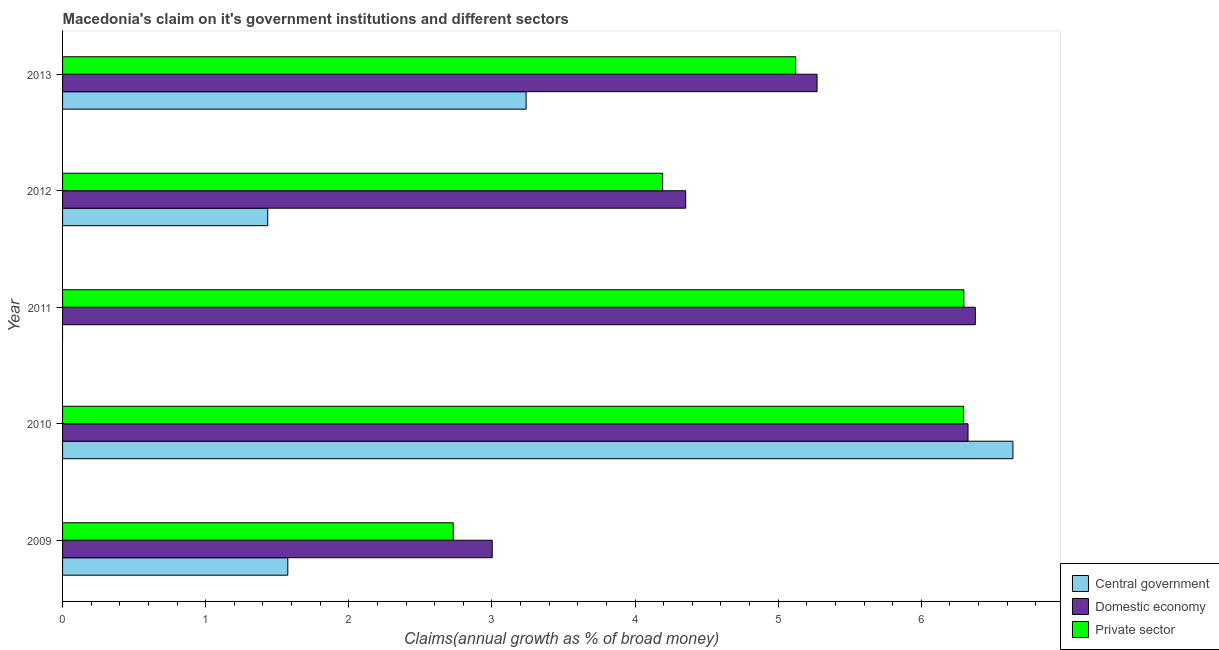How many different coloured bars are there?
Offer a terse response. 3. How many groups of bars are there?
Give a very brief answer. 5. How many bars are there on the 4th tick from the top?
Provide a succinct answer. 3. In how many cases, is the number of bars for a given year not equal to the number of legend labels?
Offer a terse response. 1. Across all years, what is the maximum percentage of claim on the central government?
Your answer should be compact. 6.64. Across all years, what is the minimum percentage of claim on the private sector?
Provide a short and direct response. 2.73. What is the total percentage of claim on the domestic economy in the graph?
Offer a terse response. 25.33. What is the difference between the percentage of claim on the central government in 2009 and that in 2012?
Give a very brief answer. 0.14. What is the difference between the percentage of claim on the central government in 2012 and the percentage of claim on the domestic economy in 2013?
Offer a terse response. -3.84. What is the average percentage of claim on the central government per year?
Your answer should be compact. 2.58. In the year 2009, what is the difference between the percentage of claim on the central government and percentage of claim on the domestic economy?
Your answer should be very brief. -1.43. What is the ratio of the percentage of claim on the central government in 2009 to that in 2010?
Provide a succinct answer. 0.24. What is the difference between the highest and the second highest percentage of claim on the central government?
Your answer should be compact. 3.4. What is the difference between the highest and the lowest percentage of claim on the private sector?
Give a very brief answer. 3.57. In how many years, is the percentage of claim on the central government greater than the average percentage of claim on the central government taken over all years?
Provide a succinct answer. 2. Is the sum of the percentage of claim on the private sector in 2009 and 2013 greater than the maximum percentage of claim on the central government across all years?
Offer a very short reply. Yes. Is it the case that in every year, the sum of the percentage of claim on the central government and percentage of claim on the domestic economy is greater than the percentage of claim on the private sector?
Give a very brief answer. Yes. Are all the bars in the graph horizontal?
Ensure brevity in your answer.  Yes. How many years are there in the graph?
Your answer should be very brief. 5. What is the difference between two consecutive major ticks on the X-axis?
Offer a terse response. 1. Does the graph contain grids?
Provide a succinct answer. No. How many legend labels are there?
Offer a very short reply. 3. What is the title of the graph?
Offer a terse response. Macedonia's claim on it's government institutions and different sectors. What is the label or title of the X-axis?
Ensure brevity in your answer.  Claims(annual growth as % of broad money). What is the Claims(annual growth as % of broad money) in Central government in 2009?
Provide a succinct answer. 1.57. What is the Claims(annual growth as % of broad money) of Domestic economy in 2009?
Provide a short and direct response. 3. What is the Claims(annual growth as % of broad money) in Private sector in 2009?
Make the answer very short. 2.73. What is the Claims(annual growth as % of broad money) in Central government in 2010?
Offer a terse response. 6.64. What is the Claims(annual growth as % of broad money) of Domestic economy in 2010?
Provide a short and direct response. 6.33. What is the Claims(annual growth as % of broad money) of Private sector in 2010?
Ensure brevity in your answer.  6.3. What is the Claims(annual growth as % of broad money) in Central government in 2011?
Provide a short and direct response. 0. What is the Claims(annual growth as % of broad money) of Domestic economy in 2011?
Your answer should be very brief. 6.38. What is the Claims(annual growth as % of broad money) of Private sector in 2011?
Provide a succinct answer. 6.3. What is the Claims(annual growth as % of broad money) of Central government in 2012?
Provide a succinct answer. 1.43. What is the Claims(annual growth as % of broad money) of Domestic economy in 2012?
Give a very brief answer. 4.35. What is the Claims(annual growth as % of broad money) of Private sector in 2012?
Keep it short and to the point. 4.19. What is the Claims(annual growth as % of broad money) in Central government in 2013?
Your answer should be very brief. 3.24. What is the Claims(annual growth as % of broad money) of Domestic economy in 2013?
Provide a succinct answer. 5.27. What is the Claims(annual growth as % of broad money) of Private sector in 2013?
Provide a short and direct response. 5.12. Across all years, what is the maximum Claims(annual growth as % of broad money) of Central government?
Your response must be concise. 6.64. Across all years, what is the maximum Claims(annual growth as % of broad money) of Domestic economy?
Your answer should be very brief. 6.38. Across all years, what is the maximum Claims(annual growth as % of broad money) in Private sector?
Ensure brevity in your answer.  6.3. Across all years, what is the minimum Claims(annual growth as % of broad money) in Domestic economy?
Your answer should be very brief. 3. Across all years, what is the minimum Claims(annual growth as % of broad money) in Private sector?
Make the answer very short. 2.73. What is the total Claims(annual growth as % of broad money) in Central government in the graph?
Keep it short and to the point. 12.89. What is the total Claims(annual growth as % of broad money) in Domestic economy in the graph?
Ensure brevity in your answer.  25.33. What is the total Claims(annual growth as % of broad money) in Private sector in the graph?
Keep it short and to the point. 24.64. What is the difference between the Claims(annual growth as % of broad money) of Central government in 2009 and that in 2010?
Offer a very short reply. -5.07. What is the difference between the Claims(annual growth as % of broad money) in Domestic economy in 2009 and that in 2010?
Give a very brief answer. -3.32. What is the difference between the Claims(annual growth as % of broad money) of Private sector in 2009 and that in 2010?
Give a very brief answer. -3.57. What is the difference between the Claims(annual growth as % of broad money) of Domestic economy in 2009 and that in 2011?
Give a very brief answer. -3.38. What is the difference between the Claims(annual growth as % of broad money) of Private sector in 2009 and that in 2011?
Keep it short and to the point. -3.57. What is the difference between the Claims(annual growth as % of broad money) of Central government in 2009 and that in 2012?
Your answer should be compact. 0.14. What is the difference between the Claims(annual growth as % of broad money) of Domestic economy in 2009 and that in 2012?
Make the answer very short. -1.35. What is the difference between the Claims(annual growth as % of broad money) in Private sector in 2009 and that in 2012?
Your answer should be compact. -1.46. What is the difference between the Claims(annual growth as % of broad money) in Central government in 2009 and that in 2013?
Give a very brief answer. -1.67. What is the difference between the Claims(annual growth as % of broad money) of Domestic economy in 2009 and that in 2013?
Your answer should be compact. -2.27. What is the difference between the Claims(annual growth as % of broad money) in Private sector in 2009 and that in 2013?
Your response must be concise. -2.39. What is the difference between the Claims(annual growth as % of broad money) of Domestic economy in 2010 and that in 2011?
Make the answer very short. -0.05. What is the difference between the Claims(annual growth as % of broad money) of Private sector in 2010 and that in 2011?
Offer a very short reply. -0. What is the difference between the Claims(annual growth as % of broad money) of Central government in 2010 and that in 2012?
Provide a succinct answer. 5.21. What is the difference between the Claims(annual growth as % of broad money) of Domestic economy in 2010 and that in 2012?
Keep it short and to the point. 1.97. What is the difference between the Claims(annual growth as % of broad money) of Private sector in 2010 and that in 2012?
Offer a terse response. 2.1. What is the difference between the Claims(annual growth as % of broad money) of Central government in 2010 and that in 2013?
Provide a short and direct response. 3.4. What is the difference between the Claims(annual growth as % of broad money) of Domestic economy in 2010 and that in 2013?
Ensure brevity in your answer.  1.05. What is the difference between the Claims(annual growth as % of broad money) of Private sector in 2010 and that in 2013?
Offer a very short reply. 1.17. What is the difference between the Claims(annual growth as % of broad money) in Domestic economy in 2011 and that in 2012?
Offer a very short reply. 2.02. What is the difference between the Claims(annual growth as % of broad money) of Private sector in 2011 and that in 2012?
Keep it short and to the point. 2.1. What is the difference between the Claims(annual growth as % of broad money) of Domestic economy in 2011 and that in 2013?
Provide a succinct answer. 1.11. What is the difference between the Claims(annual growth as % of broad money) of Private sector in 2011 and that in 2013?
Make the answer very short. 1.18. What is the difference between the Claims(annual growth as % of broad money) in Central government in 2012 and that in 2013?
Your answer should be compact. -1.81. What is the difference between the Claims(annual growth as % of broad money) in Domestic economy in 2012 and that in 2013?
Make the answer very short. -0.92. What is the difference between the Claims(annual growth as % of broad money) of Private sector in 2012 and that in 2013?
Your answer should be compact. -0.93. What is the difference between the Claims(annual growth as % of broad money) in Central government in 2009 and the Claims(annual growth as % of broad money) in Domestic economy in 2010?
Ensure brevity in your answer.  -4.75. What is the difference between the Claims(annual growth as % of broad money) of Central government in 2009 and the Claims(annual growth as % of broad money) of Private sector in 2010?
Provide a succinct answer. -4.72. What is the difference between the Claims(annual growth as % of broad money) of Domestic economy in 2009 and the Claims(annual growth as % of broad money) of Private sector in 2010?
Offer a very short reply. -3.29. What is the difference between the Claims(annual growth as % of broad money) in Central government in 2009 and the Claims(annual growth as % of broad money) in Domestic economy in 2011?
Offer a terse response. -4.8. What is the difference between the Claims(annual growth as % of broad money) in Central government in 2009 and the Claims(annual growth as % of broad money) in Private sector in 2011?
Make the answer very short. -4.72. What is the difference between the Claims(annual growth as % of broad money) of Domestic economy in 2009 and the Claims(annual growth as % of broad money) of Private sector in 2011?
Your answer should be very brief. -3.3. What is the difference between the Claims(annual growth as % of broad money) of Central government in 2009 and the Claims(annual growth as % of broad money) of Domestic economy in 2012?
Give a very brief answer. -2.78. What is the difference between the Claims(annual growth as % of broad money) of Central government in 2009 and the Claims(annual growth as % of broad money) of Private sector in 2012?
Make the answer very short. -2.62. What is the difference between the Claims(annual growth as % of broad money) of Domestic economy in 2009 and the Claims(annual growth as % of broad money) of Private sector in 2012?
Your answer should be compact. -1.19. What is the difference between the Claims(annual growth as % of broad money) in Central government in 2009 and the Claims(annual growth as % of broad money) in Domestic economy in 2013?
Your answer should be compact. -3.7. What is the difference between the Claims(annual growth as % of broad money) in Central government in 2009 and the Claims(annual growth as % of broad money) in Private sector in 2013?
Your answer should be compact. -3.55. What is the difference between the Claims(annual growth as % of broad money) in Domestic economy in 2009 and the Claims(annual growth as % of broad money) in Private sector in 2013?
Your response must be concise. -2.12. What is the difference between the Claims(annual growth as % of broad money) of Central government in 2010 and the Claims(annual growth as % of broad money) of Domestic economy in 2011?
Make the answer very short. 0.26. What is the difference between the Claims(annual growth as % of broad money) of Central government in 2010 and the Claims(annual growth as % of broad money) of Private sector in 2011?
Your response must be concise. 0.34. What is the difference between the Claims(annual growth as % of broad money) in Domestic economy in 2010 and the Claims(annual growth as % of broad money) in Private sector in 2011?
Your response must be concise. 0.03. What is the difference between the Claims(annual growth as % of broad money) of Central government in 2010 and the Claims(annual growth as % of broad money) of Domestic economy in 2012?
Provide a short and direct response. 2.29. What is the difference between the Claims(annual growth as % of broad money) in Central government in 2010 and the Claims(annual growth as % of broad money) in Private sector in 2012?
Offer a very short reply. 2.45. What is the difference between the Claims(annual growth as % of broad money) in Domestic economy in 2010 and the Claims(annual growth as % of broad money) in Private sector in 2012?
Ensure brevity in your answer.  2.13. What is the difference between the Claims(annual growth as % of broad money) of Central government in 2010 and the Claims(annual growth as % of broad money) of Domestic economy in 2013?
Provide a succinct answer. 1.37. What is the difference between the Claims(annual growth as % of broad money) of Central government in 2010 and the Claims(annual growth as % of broad money) of Private sector in 2013?
Provide a succinct answer. 1.52. What is the difference between the Claims(annual growth as % of broad money) of Domestic economy in 2010 and the Claims(annual growth as % of broad money) of Private sector in 2013?
Offer a terse response. 1.2. What is the difference between the Claims(annual growth as % of broad money) of Domestic economy in 2011 and the Claims(annual growth as % of broad money) of Private sector in 2012?
Provide a succinct answer. 2.18. What is the difference between the Claims(annual growth as % of broad money) of Domestic economy in 2011 and the Claims(annual growth as % of broad money) of Private sector in 2013?
Ensure brevity in your answer.  1.26. What is the difference between the Claims(annual growth as % of broad money) of Central government in 2012 and the Claims(annual growth as % of broad money) of Domestic economy in 2013?
Keep it short and to the point. -3.84. What is the difference between the Claims(annual growth as % of broad money) in Central government in 2012 and the Claims(annual growth as % of broad money) in Private sector in 2013?
Offer a terse response. -3.69. What is the difference between the Claims(annual growth as % of broad money) of Domestic economy in 2012 and the Claims(annual growth as % of broad money) of Private sector in 2013?
Ensure brevity in your answer.  -0.77. What is the average Claims(annual growth as % of broad money) of Central government per year?
Offer a terse response. 2.58. What is the average Claims(annual growth as % of broad money) of Domestic economy per year?
Your response must be concise. 5.07. What is the average Claims(annual growth as % of broad money) of Private sector per year?
Offer a terse response. 4.93. In the year 2009, what is the difference between the Claims(annual growth as % of broad money) of Central government and Claims(annual growth as % of broad money) of Domestic economy?
Ensure brevity in your answer.  -1.43. In the year 2009, what is the difference between the Claims(annual growth as % of broad money) of Central government and Claims(annual growth as % of broad money) of Private sector?
Make the answer very short. -1.16. In the year 2009, what is the difference between the Claims(annual growth as % of broad money) in Domestic economy and Claims(annual growth as % of broad money) in Private sector?
Offer a very short reply. 0.27. In the year 2010, what is the difference between the Claims(annual growth as % of broad money) of Central government and Claims(annual growth as % of broad money) of Domestic economy?
Ensure brevity in your answer.  0.31. In the year 2010, what is the difference between the Claims(annual growth as % of broad money) in Central government and Claims(annual growth as % of broad money) in Private sector?
Ensure brevity in your answer.  0.34. In the year 2010, what is the difference between the Claims(annual growth as % of broad money) of Domestic economy and Claims(annual growth as % of broad money) of Private sector?
Your answer should be compact. 0.03. In the year 2011, what is the difference between the Claims(annual growth as % of broad money) of Domestic economy and Claims(annual growth as % of broad money) of Private sector?
Provide a succinct answer. 0.08. In the year 2012, what is the difference between the Claims(annual growth as % of broad money) of Central government and Claims(annual growth as % of broad money) of Domestic economy?
Your response must be concise. -2.92. In the year 2012, what is the difference between the Claims(annual growth as % of broad money) of Central government and Claims(annual growth as % of broad money) of Private sector?
Offer a terse response. -2.76. In the year 2012, what is the difference between the Claims(annual growth as % of broad money) of Domestic economy and Claims(annual growth as % of broad money) of Private sector?
Offer a very short reply. 0.16. In the year 2013, what is the difference between the Claims(annual growth as % of broad money) of Central government and Claims(annual growth as % of broad money) of Domestic economy?
Provide a succinct answer. -2.03. In the year 2013, what is the difference between the Claims(annual growth as % of broad money) in Central government and Claims(annual growth as % of broad money) in Private sector?
Keep it short and to the point. -1.88. In the year 2013, what is the difference between the Claims(annual growth as % of broad money) of Domestic economy and Claims(annual growth as % of broad money) of Private sector?
Provide a short and direct response. 0.15. What is the ratio of the Claims(annual growth as % of broad money) of Central government in 2009 to that in 2010?
Make the answer very short. 0.24. What is the ratio of the Claims(annual growth as % of broad money) of Domestic economy in 2009 to that in 2010?
Your answer should be very brief. 0.47. What is the ratio of the Claims(annual growth as % of broad money) of Private sector in 2009 to that in 2010?
Make the answer very short. 0.43. What is the ratio of the Claims(annual growth as % of broad money) in Domestic economy in 2009 to that in 2011?
Ensure brevity in your answer.  0.47. What is the ratio of the Claims(annual growth as % of broad money) in Private sector in 2009 to that in 2011?
Ensure brevity in your answer.  0.43. What is the ratio of the Claims(annual growth as % of broad money) in Central government in 2009 to that in 2012?
Your response must be concise. 1.1. What is the ratio of the Claims(annual growth as % of broad money) of Domestic economy in 2009 to that in 2012?
Offer a terse response. 0.69. What is the ratio of the Claims(annual growth as % of broad money) in Private sector in 2009 to that in 2012?
Provide a short and direct response. 0.65. What is the ratio of the Claims(annual growth as % of broad money) in Central government in 2009 to that in 2013?
Offer a very short reply. 0.49. What is the ratio of the Claims(annual growth as % of broad money) of Domestic economy in 2009 to that in 2013?
Provide a short and direct response. 0.57. What is the ratio of the Claims(annual growth as % of broad money) in Private sector in 2009 to that in 2013?
Your answer should be very brief. 0.53. What is the ratio of the Claims(annual growth as % of broad money) in Domestic economy in 2010 to that in 2011?
Provide a short and direct response. 0.99. What is the ratio of the Claims(annual growth as % of broad money) of Central government in 2010 to that in 2012?
Provide a short and direct response. 4.63. What is the ratio of the Claims(annual growth as % of broad money) of Domestic economy in 2010 to that in 2012?
Your answer should be compact. 1.45. What is the ratio of the Claims(annual growth as % of broad money) of Private sector in 2010 to that in 2012?
Your answer should be very brief. 1.5. What is the ratio of the Claims(annual growth as % of broad money) in Central government in 2010 to that in 2013?
Provide a short and direct response. 2.05. What is the ratio of the Claims(annual growth as % of broad money) of Domestic economy in 2010 to that in 2013?
Your response must be concise. 1.2. What is the ratio of the Claims(annual growth as % of broad money) in Private sector in 2010 to that in 2013?
Provide a succinct answer. 1.23. What is the ratio of the Claims(annual growth as % of broad money) in Domestic economy in 2011 to that in 2012?
Your answer should be compact. 1.46. What is the ratio of the Claims(annual growth as % of broad money) of Private sector in 2011 to that in 2012?
Give a very brief answer. 1.5. What is the ratio of the Claims(annual growth as % of broad money) in Domestic economy in 2011 to that in 2013?
Offer a terse response. 1.21. What is the ratio of the Claims(annual growth as % of broad money) of Private sector in 2011 to that in 2013?
Keep it short and to the point. 1.23. What is the ratio of the Claims(annual growth as % of broad money) of Central government in 2012 to that in 2013?
Offer a terse response. 0.44. What is the ratio of the Claims(annual growth as % of broad money) of Domestic economy in 2012 to that in 2013?
Your response must be concise. 0.83. What is the ratio of the Claims(annual growth as % of broad money) in Private sector in 2012 to that in 2013?
Your response must be concise. 0.82. What is the difference between the highest and the second highest Claims(annual growth as % of broad money) of Central government?
Provide a short and direct response. 3.4. What is the difference between the highest and the second highest Claims(annual growth as % of broad money) of Domestic economy?
Offer a very short reply. 0.05. What is the difference between the highest and the second highest Claims(annual growth as % of broad money) of Private sector?
Make the answer very short. 0. What is the difference between the highest and the lowest Claims(annual growth as % of broad money) in Central government?
Keep it short and to the point. 6.64. What is the difference between the highest and the lowest Claims(annual growth as % of broad money) of Domestic economy?
Give a very brief answer. 3.38. What is the difference between the highest and the lowest Claims(annual growth as % of broad money) of Private sector?
Provide a succinct answer. 3.57. 